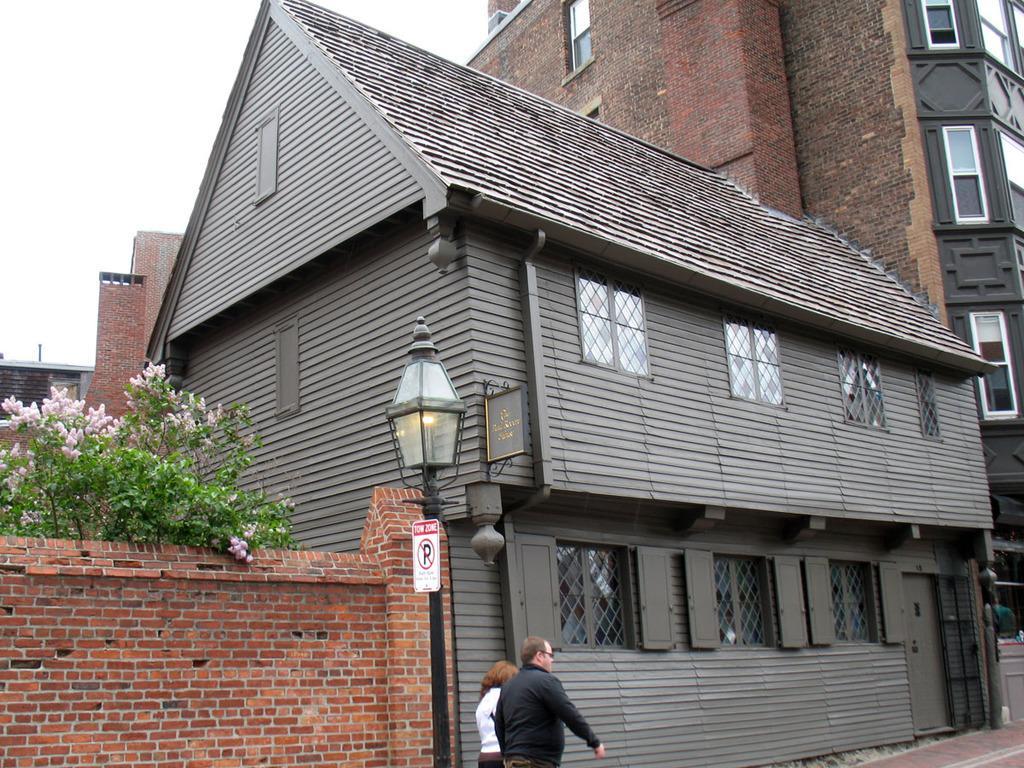Please provide a concise description of this image. In this image I can see two people with white and black color dress. To the side of these people I can see the house which is in grey and brown color. I can also see the light pole in-front of the house. To the left I can see the plant with flowers. In the back there is a white sky. 